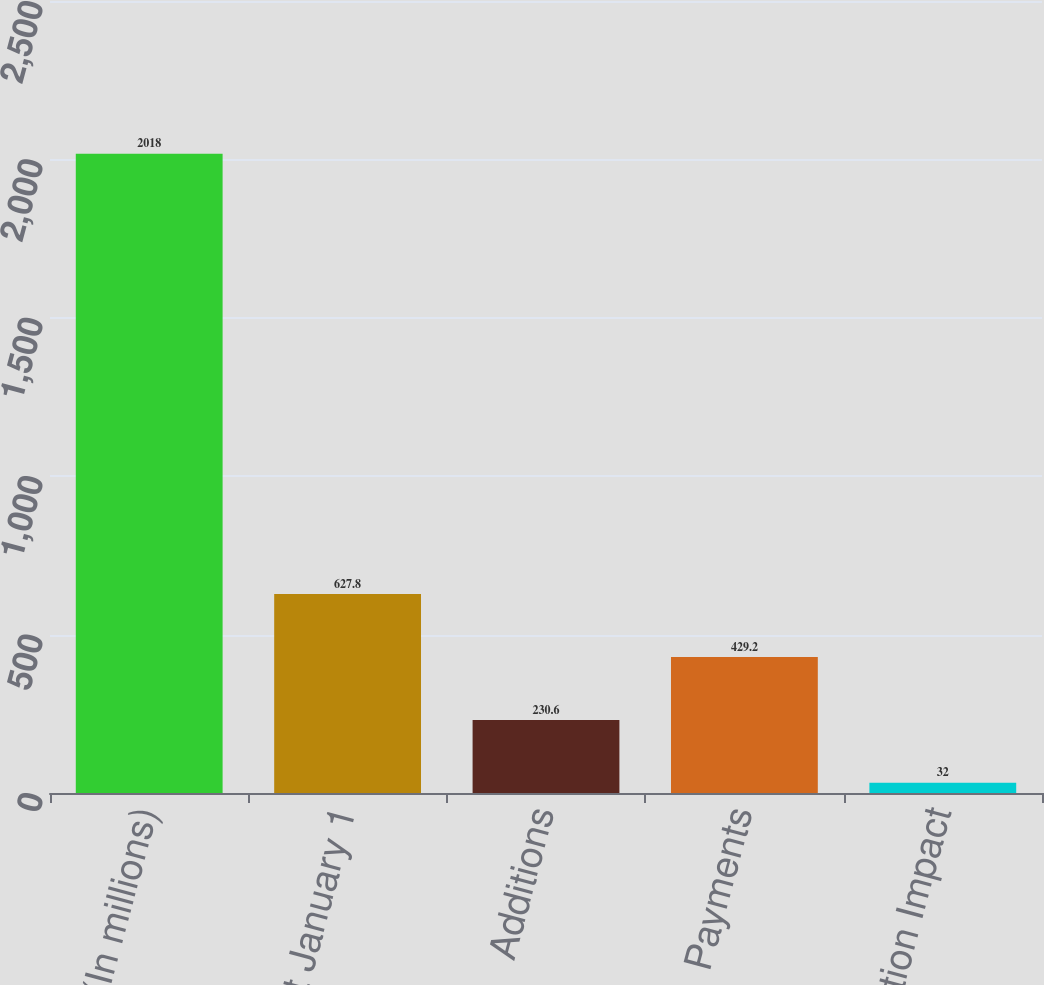Convert chart to OTSL. <chart><loc_0><loc_0><loc_500><loc_500><bar_chart><fcel>(In millions)<fcel>Balance at January 1<fcel>Additions<fcel>Payments<fcel>Revaluation Impact<nl><fcel>2018<fcel>627.8<fcel>230.6<fcel>429.2<fcel>32<nl></chart> 